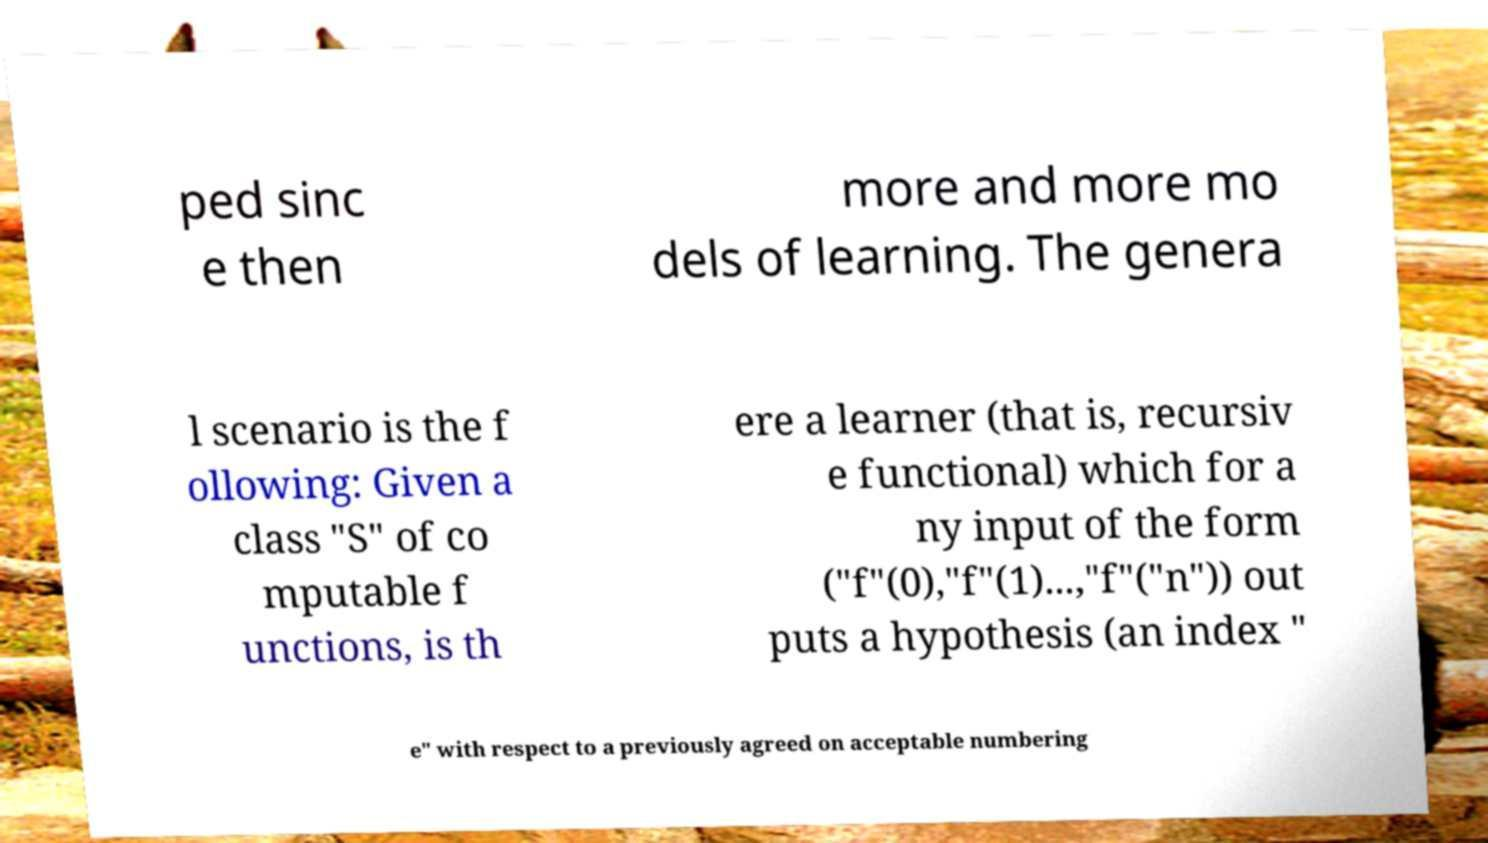Please identify and transcribe the text found in this image. ped sinc e then more and more mo dels of learning. The genera l scenario is the f ollowing: Given a class "S" of co mputable f unctions, is th ere a learner (that is, recursiv e functional) which for a ny input of the form ("f"(0),"f"(1)...,"f"("n")) out puts a hypothesis (an index " e" with respect to a previously agreed on acceptable numbering 